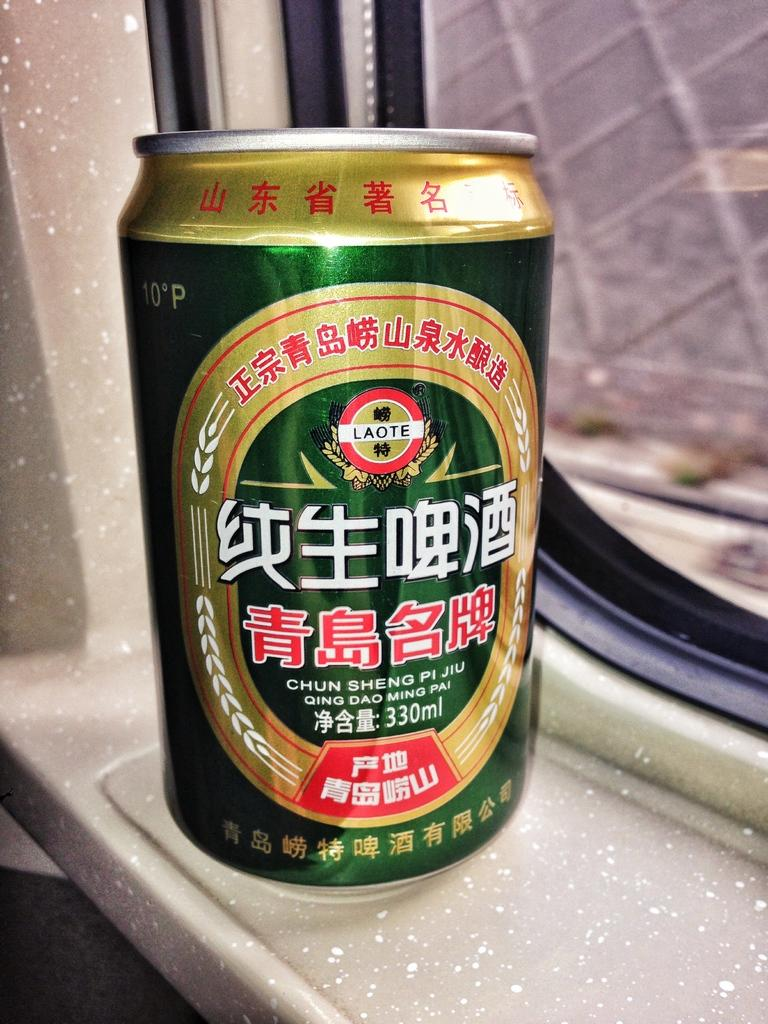<image>
Give a short and clear explanation of the subsequent image. A green and gold can has the words CHUN SHENG PI JIU on it. 